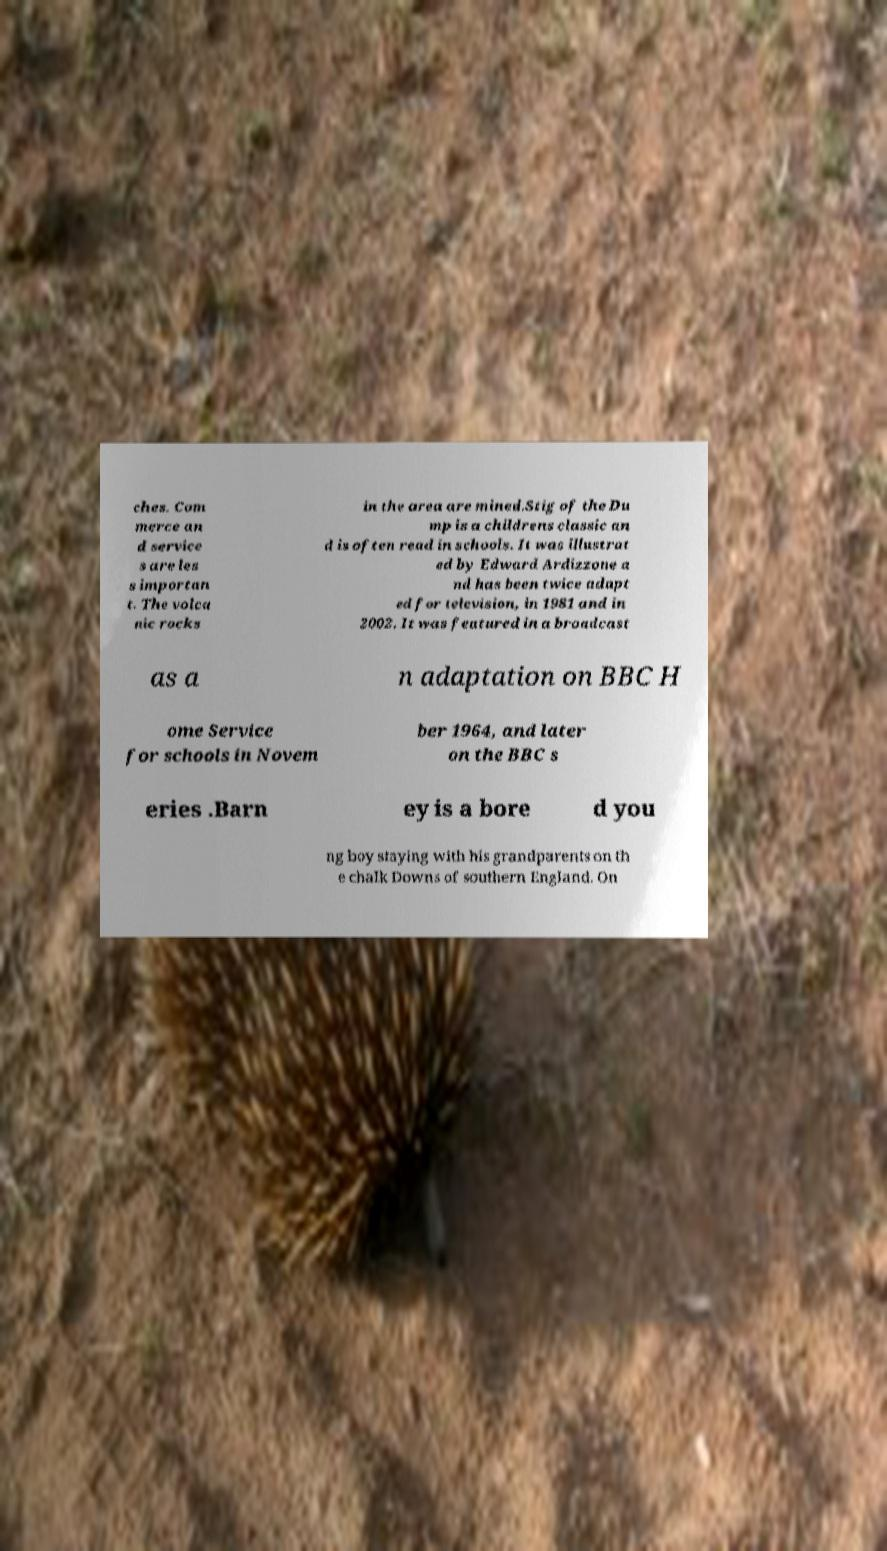What messages or text are displayed in this image? I need them in a readable, typed format. ches. Com merce an d service s are les s importan t. The volca nic rocks in the area are mined.Stig of the Du mp is a childrens classic an d is often read in schools. It was illustrat ed by Edward Ardizzone a nd has been twice adapt ed for television, in 1981 and in 2002. It was featured in a broadcast as a n adaptation on BBC H ome Service for schools in Novem ber 1964, and later on the BBC s eries .Barn ey is a bore d you ng boy staying with his grandparents on th e chalk Downs of southern England. On 